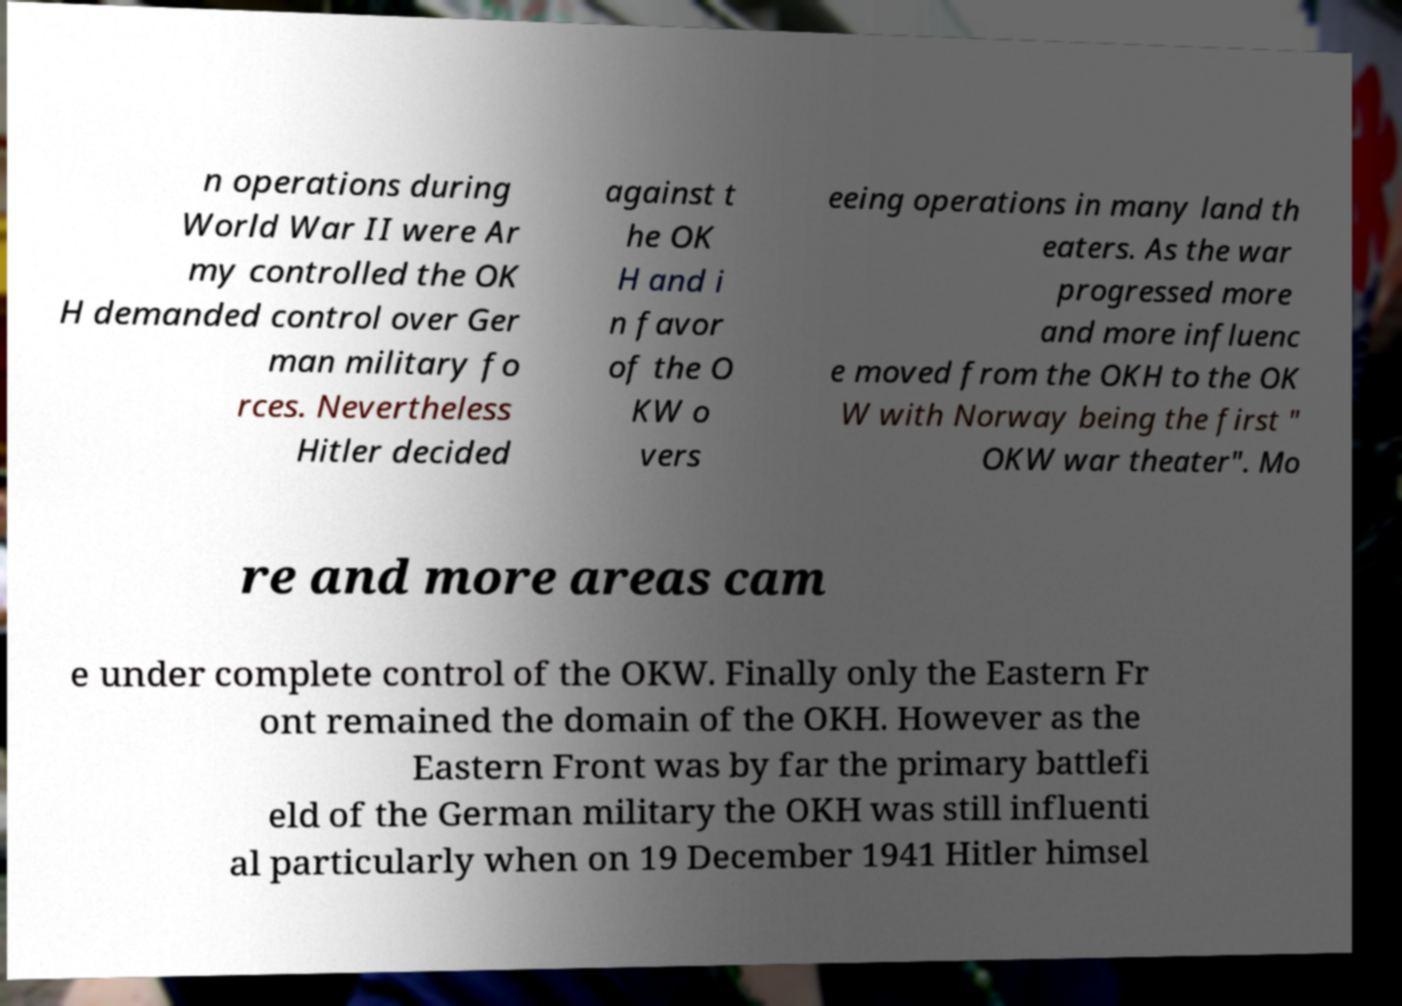Can you accurately transcribe the text from the provided image for me? n operations during World War II were Ar my controlled the OK H demanded control over Ger man military fo rces. Nevertheless Hitler decided against t he OK H and i n favor of the O KW o vers eeing operations in many land th eaters. As the war progressed more and more influenc e moved from the OKH to the OK W with Norway being the first " OKW war theater". Mo re and more areas cam e under complete control of the OKW. Finally only the Eastern Fr ont remained the domain of the OKH. However as the Eastern Front was by far the primary battlefi eld of the German military the OKH was still influenti al particularly when on 19 December 1941 Hitler himsel 